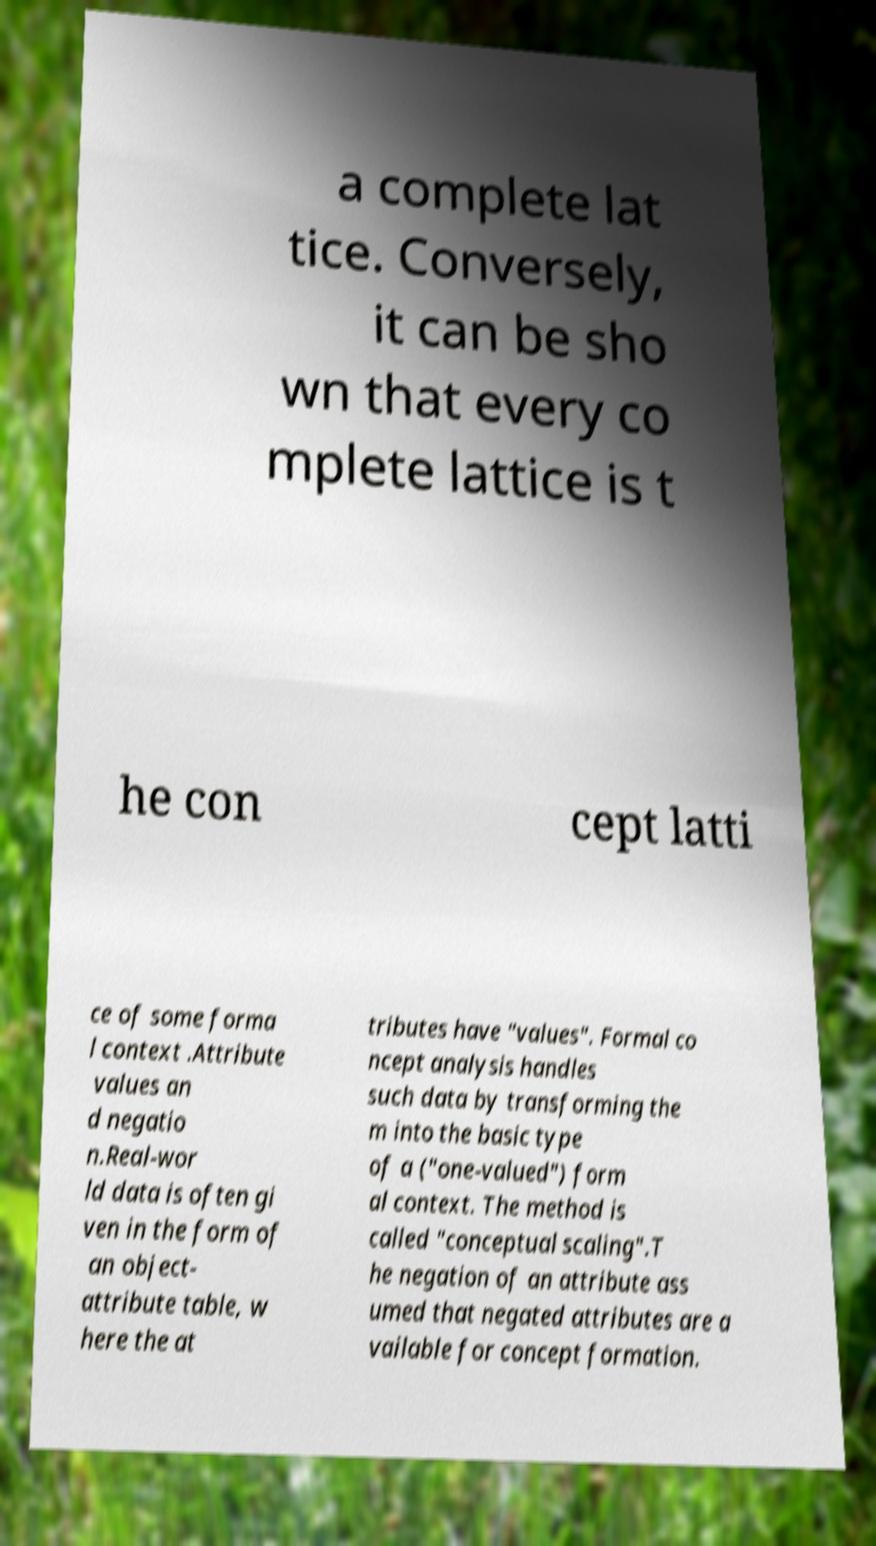What messages or text are displayed in this image? I need them in a readable, typed format. a complete lat tice. Conversely, it can be sho wn that every co mplete lattice is t he con cept latti ce of some forma l context .Attribute values an d negatio n.Real-wor ld data is often gi ven in the form of an object- attribute table, w here the at tributes have "values". Formal co ncept analysis handles such data by transforming the m into the basic type of a ("one-valued") form al context. The method is called "conceptual scaling".T he negation of an attribute ass umed that negated attributes are a vailable for concept formation. 